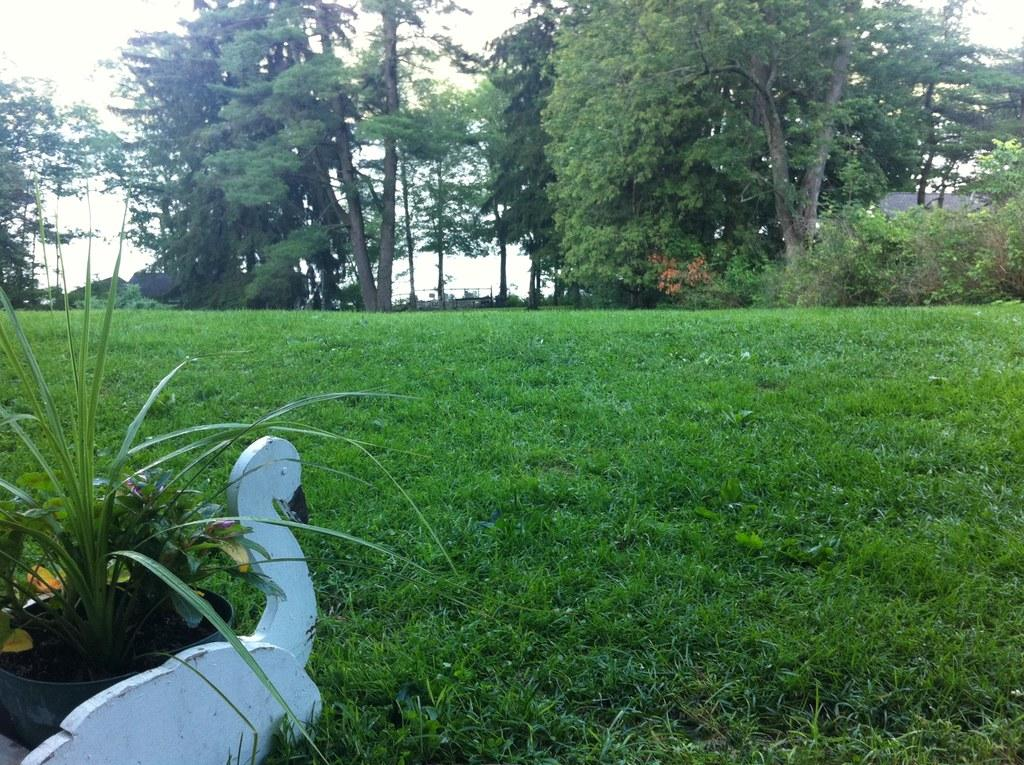What is located on the left side of the image? There is a house plant in a pot on a bird sculpture on the left side of the image. What can be seen on the ground in the background of the image? There is grass on the ground in the background of the image. What type of vegetation is visible in the background of the image? There are trees in the background of the image. What type of structures can be seen in the background of the image? There are houses in the background of the image. What else is visible in the background of the image? There are other objects in the background of the image. What is visible at the top of the image? The sky is visible in the background of the image. How many journeys are depicted in the image? There are no journeys depicted in the image. --- Facts: 1. There is a person in the image. 12. The person is wearing a red shirt. 13. The person is holding a book. 14. The book has a blue cover. 15. The person is standing on a wooden floor. 16. There is a window in the background of the image. 17. The window has curtains. 18. The curtains are white. 19. The person is smiling. Absurd Topics: elephant, piano, cake Conversation: What is in the image? There is a person in the image. What is the person wearing? The person is wearing a red shirt. What is the person holding? The person is holding a book. What is the color of the book's cover? The book has a blue cover. What type of surface is the person standing on? The person is standing on a wooden floor. What can be seen in the background of the image? There is a window in the background of the image. What type of window is present in the image? The window has curtains. What color are the curtains? The curtains are white. What is the expression on the person's face? The person is smiling. Reasoning: Let's think step by step in order to produce the conversation. We start by identifying the main subject in the image, which is the person. Then, we describe specific features of the person, such as their clothing and the object they are holding. Next, we observe the surroundings of the person, noting the wooden floor and the window with curtains in the background. Finally, we describe the person's expression, which is a smile. Absurd Question/Answer: Can you hear the elephant playing the piano in the image? There is no elephant or piano present in the image. --- Facts: 1. There is a person in the image 